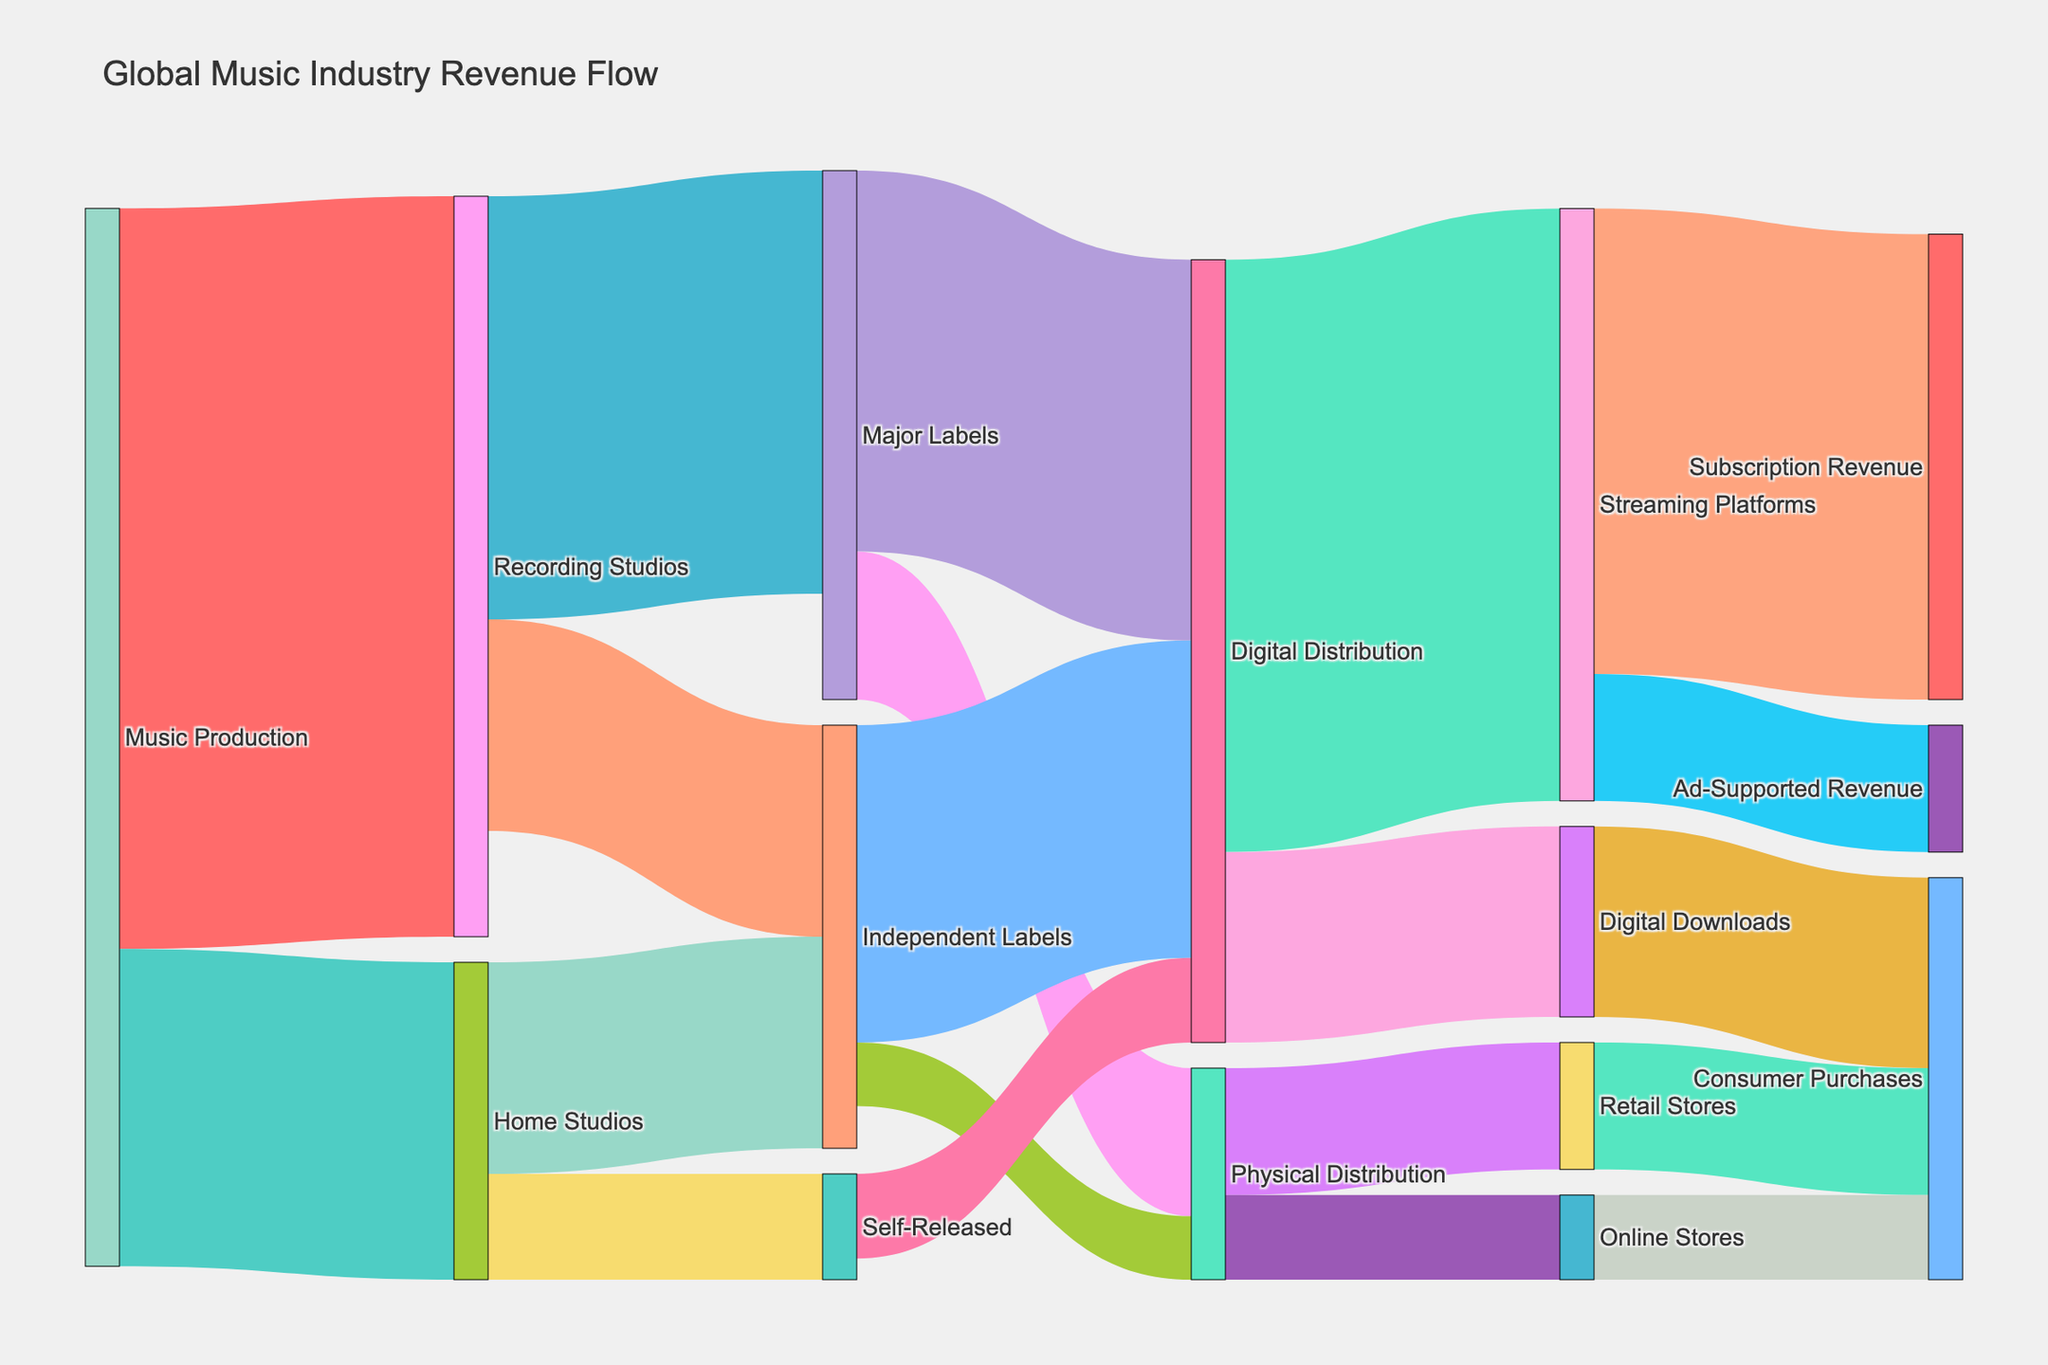What's the title of the figure? The title is located at the top of the figure and is given as “Global Music Industry Revenue Flow”.
Answer: Global Music Industry Revenue Flow What is the largest source of revenue for Digital Distribution? To determine the largest source of revenue for Digital Distribution, look at the outgoing flows to Streaming Platforms and Digital Downloads and sum them up: 2800 (Streaming Platforms) and 900 (Digital Downloads). Hence, the largest source of income for Digital Distribution is 2800.
Answer: Streaming Platforms How much revenue does Major Labels get from Recording Studios? The link between Recording Studios and Major Labels shows the value directly in the figure.
Answer: 2000 Which distribution method has a higher revenue: Digital Distribution or Physical Distribution from Independent Labels? Digital Distribution from Independent Labels has a value of 1500, whereas Physical Distribution from Independent Labels has a value of 300. 1500 is greater than 300, so Digital Distribution has a higher revenue.
Answer: Digital Distribution What is the combined revenue produced by Home Studios? The Home Studios revenue flows are split into Independent Labels (1000) and Self-Released (500). Add these two values: 1000 + 500.
Answer: 1500 What’s the total revenue flow into Streaming Platforms from all sources? The total revenue into Streaming Platforms is the sum of inflows from Digital Distribution (2800).
Answer: 2800 How does Subscription Revenue from Streaming Platforms compare to Ad-Supported Revenue from the same? Subscription Revenue from Streaming Platforms is 2200, while Ad-Supported Revenue is 600. Comparing 2200 and 600 shows that Subscription Revenue is much higher.
Answer: Subscription Revenue is higher What is the total consumer purchase revenue from all distribution channels? Consumer purchase revenues are from Digital Downloads (900), Retail Stores (600), and Online Stores (400). Summing these values gives 900 + 600 + 400.
Answer: 1900 What is the flow of revenue from Independent Labels to Physical Distribution? The value for the revenue flow from Independent Labels to Physical Distribution can be directly seen.
Answer: 300 Which has a higher revenue: Recording Studios’ Major Labels or Digital Distribution’s Digital Downloads? Comparing the values, Major Labels’ revenue from Recording Studios is 2000, whereas Digital Downloads’ revenue from Digital Distribution is 900. 2000 is higher than 900.
Answer: Recording Studios’ Major Labels 